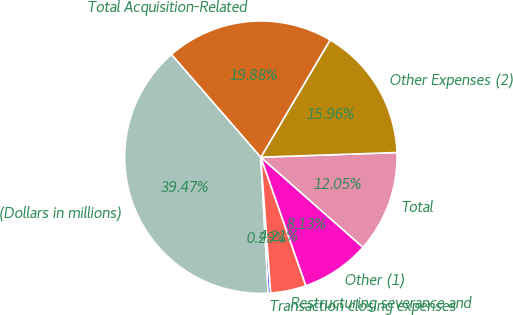Convert chart. <chart><loc_0><loc_0><loc_500><loc_500><pie_chart><fcel>(Dollars in millions)<fcel>Transaction closing expenses<fcel>Restructuring severance and<fcel>Other (1)<fcel>Total<fcel>Other Expenses (2)<fcel>Total Acquisition-Related<nl><fcel>39.47%<fcel>0.29%<fcel>4.21%<fcel>8.13%<fcel>12.05%<fcel>15.96%<fcel>19.88%<nl></chart> 